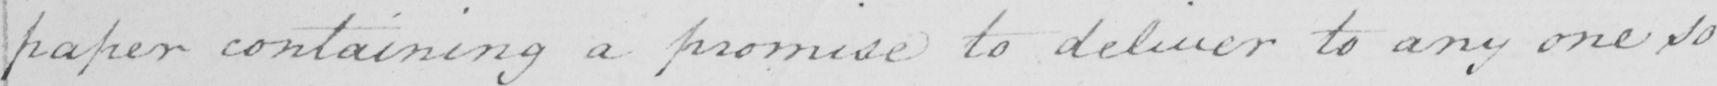Transcribe the text shown in this historical manuscript line. paper containing a promise to deliver to any one so 